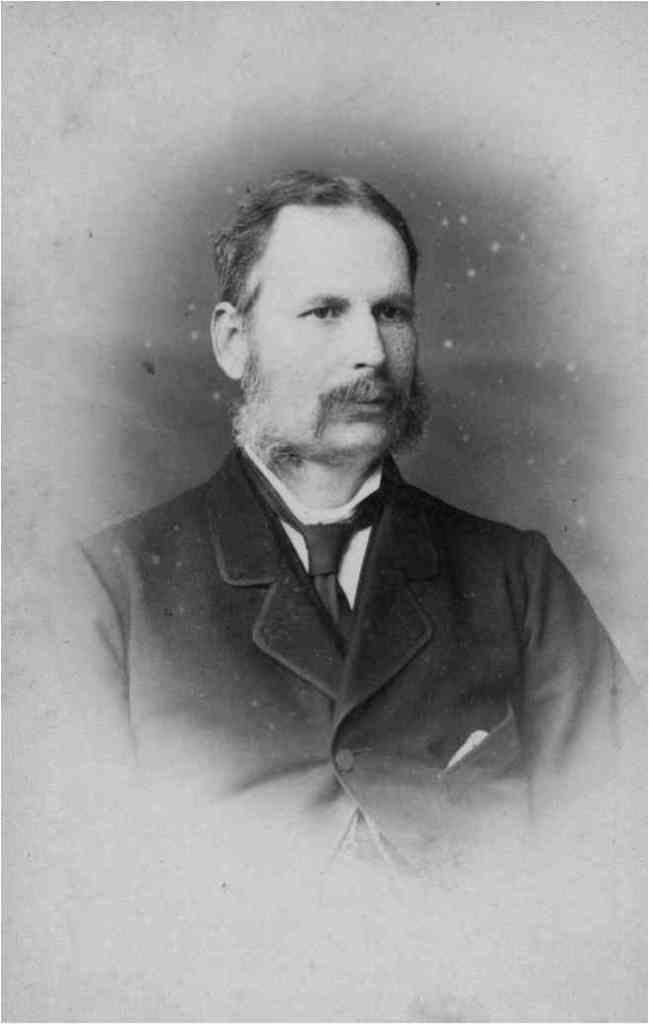What is the main subject of the image? There is a picture of a person in the image. How many ants can be seen crawling on the person's face in the image? There are no ants present in the image; it features a picture of a person. What type of curve is visible in the person's hair in the image? The image does not provide enough detail to determine the specific type of curve in the person's hair. 